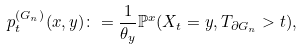<formula> <loc_0><loc_0><loc_500><loc_500>p ^ { ( G _ { n } ) } _ { t } ( x , y ) \colon = \frac { 1 } { \theta _ { y } } \mathbb { P } ^ { x } ( X _ { t } = y , T _ { \partial G _ { n } } > t ) ,</formula> 